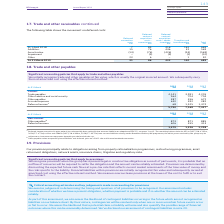According to Bt Group Plc's financial document, What was the impact on deferred income on on adoption of IFRS 15? Deferred income recognised in prior periods has substantially been reclassified to contract liabilities on adoption of IFRS 15. The document states: "a Deferred income recognised in prior periods has substantially been reclassified to contract liabilities on adoption of IFRS 15, see notes 1 and 2. T..." Also, What was the remaining balance current liabilities relating to the Broadband Delivery UK programme? The remaining balance includes £51m (2017/18: £132m, 2016/17: £71m) current. The document states: "lities on adoption of IFRS 15, see notes 1 and 2. The remaining balance includes £51m (2017/18: £132m, 2016/17: £71m) current and £586m (2017/18: £404..." Also, What is the Other payables for 2019? According to the financial document, 387 (in millions). The relevant text states: "on and social security 564 704 704 Other payables 387 456 672 Accrued expenses 630 492 382 Deferred income a 68 1,525 1,474..." Also, can you calculate: What is the change in Current: Trade payables from 2018 to 2019? Based on the calculation: 4,141-3,991, the result is 150 (in millions). This is based on the information: "Current Trade payables 4,141 3,991 4,205 Other taxation and social security 564 704 704 Other payables 387 456 672 Accrued expen Current Trade payables 4,141 3,991 4,205 Other taxation and social secu..." The key data points involved are: 3,991, 4,141. Also, can you calculate: What is the change in Current: Other taxation and social security from 2019 to 2018? Based on the calculation: 564-704, the result is -140 (in millions). This is based on the information: "41 3,991 4,205 Other taxation and social security 564 704 704 Other payables 387 456 672 Accrued expenses 630 492 382 Deferred income a 68 1,525 1,474 ,991 4,205 Other taxation and social security 564..." The key data points involved are: 564, 704. Also, can you calculate: What is the change in Current: Other payables from 2019 to 2018? Based on the calculation: 387-456, the result is -69 (in millions). This is based on the information: "on and social security 564 704 704 Other payables 387 456 672 Accrued expenses 630 492 382 Deferred income a 68 1,525 1,474 nd social security 564 704 704 Other payables 387 456 672 Accrued expenses 6..." The key data points involved are: 387, 456. 